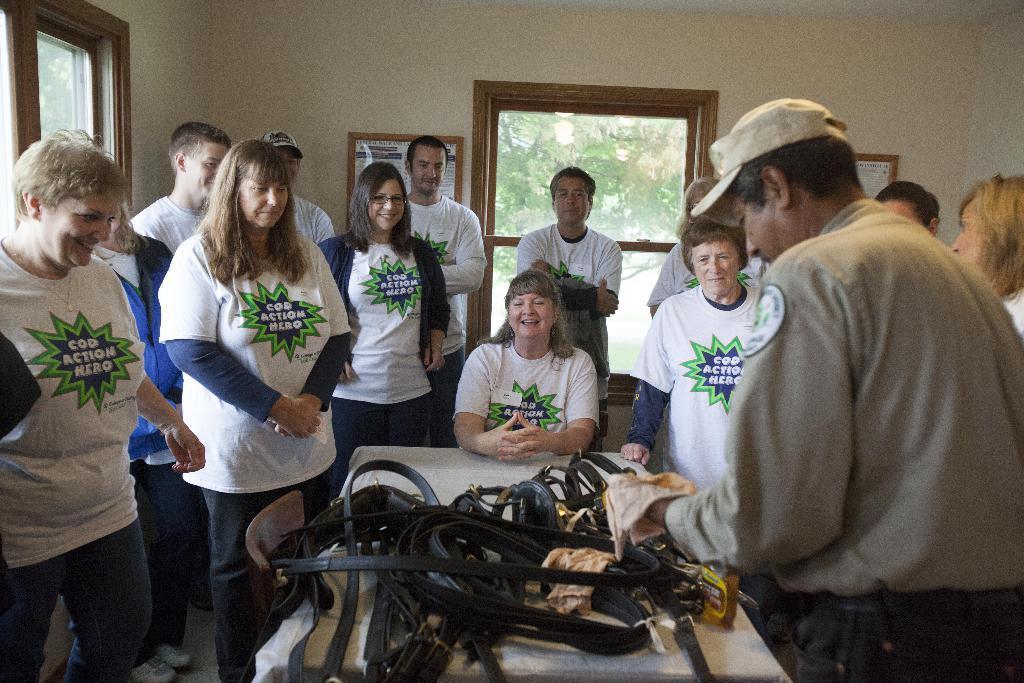Describe this image in one or two sentences. This image is taken indoors. In the background there is a wall with two frames on it. There is a road and there is a window. In the middle of the image there is a table with many things on it. There is an empty chair. Many people are standing and a woman is sitting on the chair. 